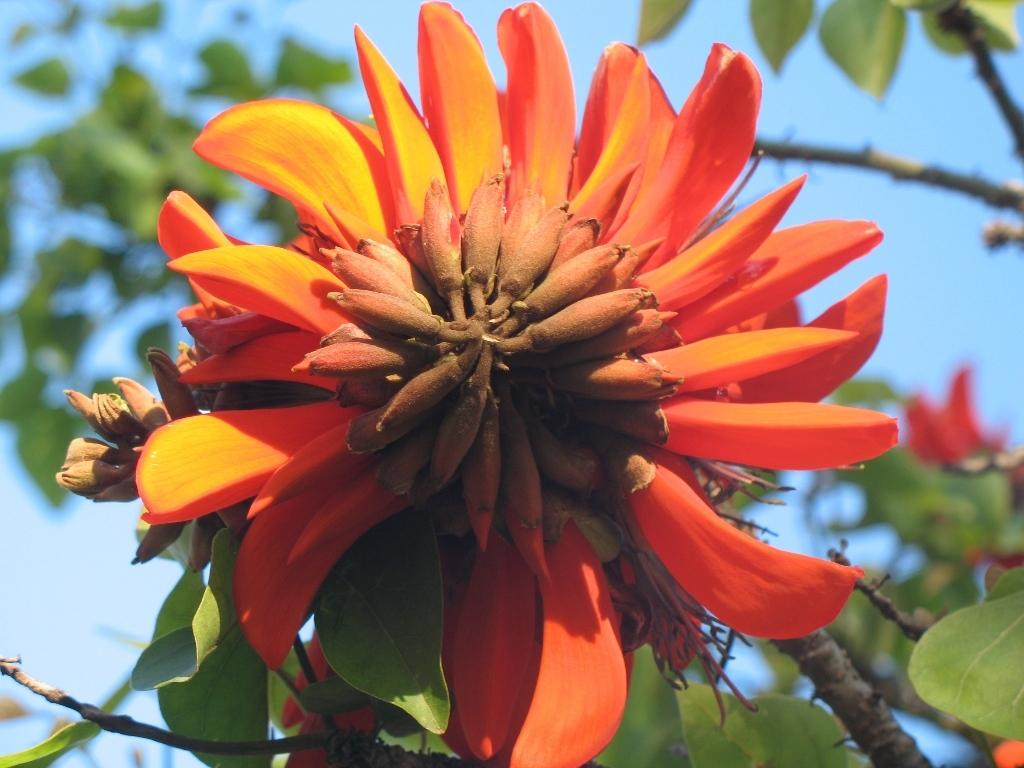What is the main subject of the image? There is a flower in the image. Can you describe the colors of the flower? The flower has yellow, orange, orange, and brown colors. What can be seen in the background of the image? There are trees in the background of the image. What color are the trees? The trees are green. What color is the sky in the image? The sky is blue. What type of plough can be seen in the image? There is no plough present in the image; it features a flower and trees in the background. Is there a jail visible in the image? No, there is no jail present in the image. 